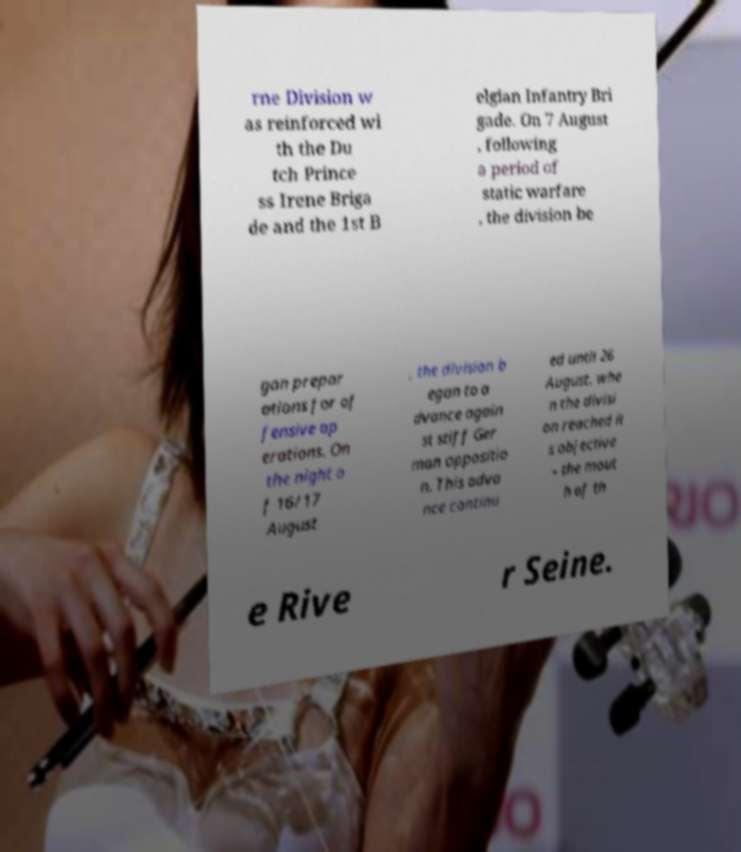Could you extract and type out the text from this image? rne Division w as reinforced wi th the Du tch Prince ss Irene Briga de and the 1st B elgian Infantry Bri gade. On 7 August , following a period of static warfare , the division be gan prepar ations for of fensive op erations. On the night o f 16/17 August , the division b egan to a dvance again st stiff Ger man oppositio n. This adva nce continu ed until 26 August, whe n the divisi on reached it s objective – the mout h of th e Rive r Seine. 